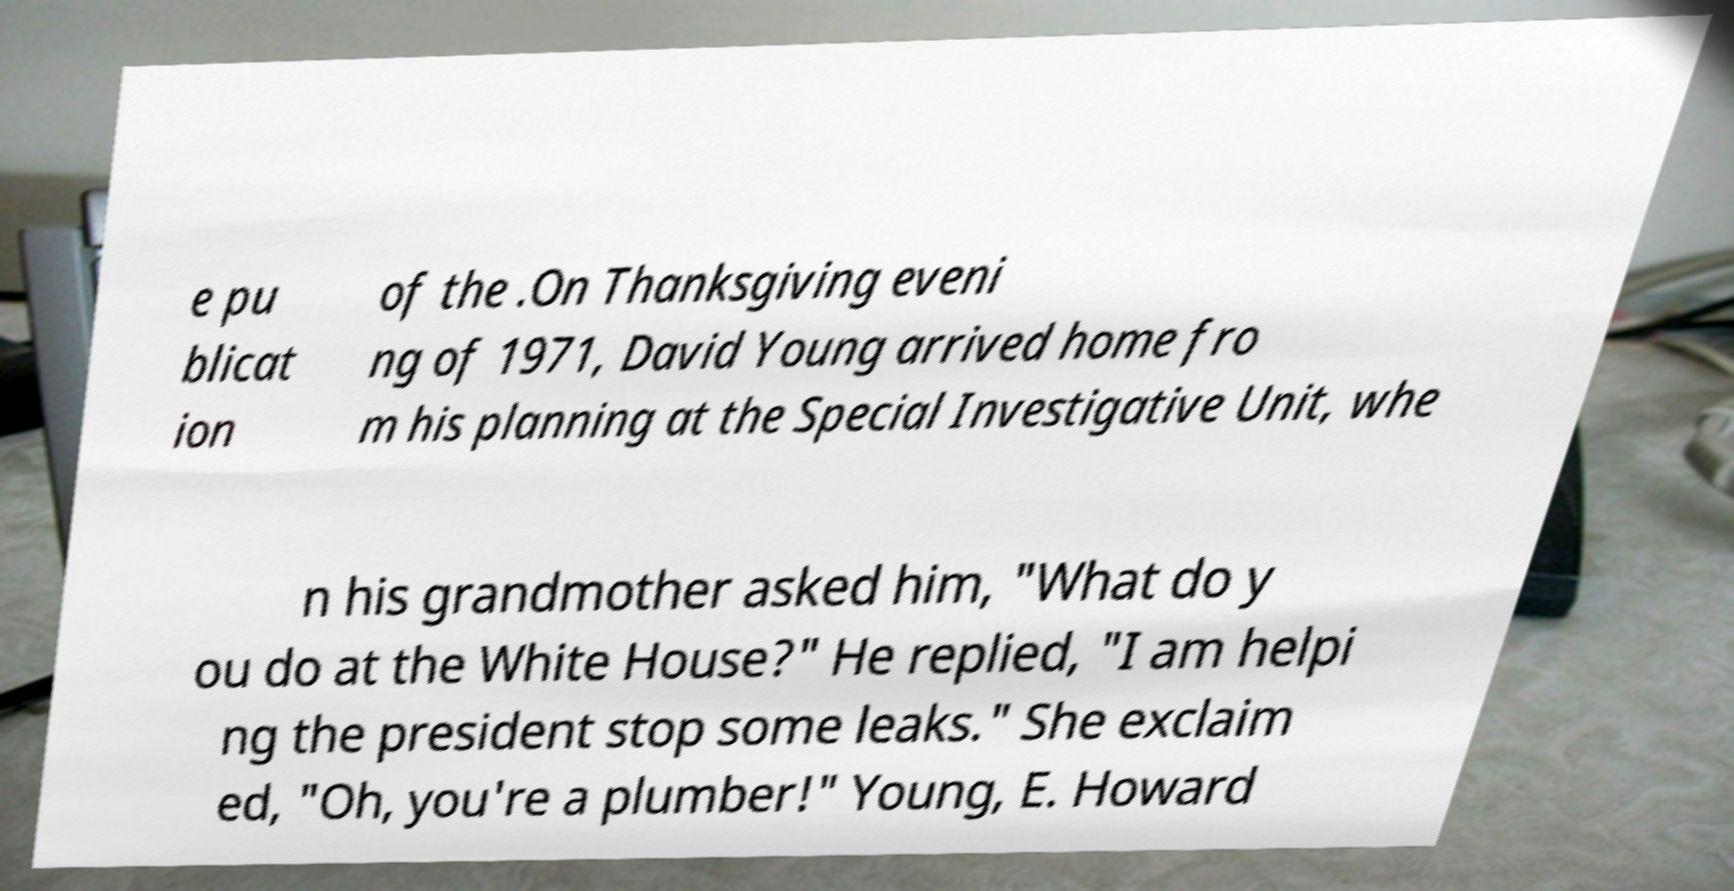I need the written content from this picture converted into text. Can you do that? e pu blicat ion of the .On Thanksgiving eveni ng of 1971, David Young arrived home fro m his planning at the Special Investigative Unit, whe n his grandmother asked him, "What do y ou do at the White House?" He replied, "I am helpi ng the president stop some leaks." She exclaim ed, "Oh, you're a plumber!" Young, E. Howard 